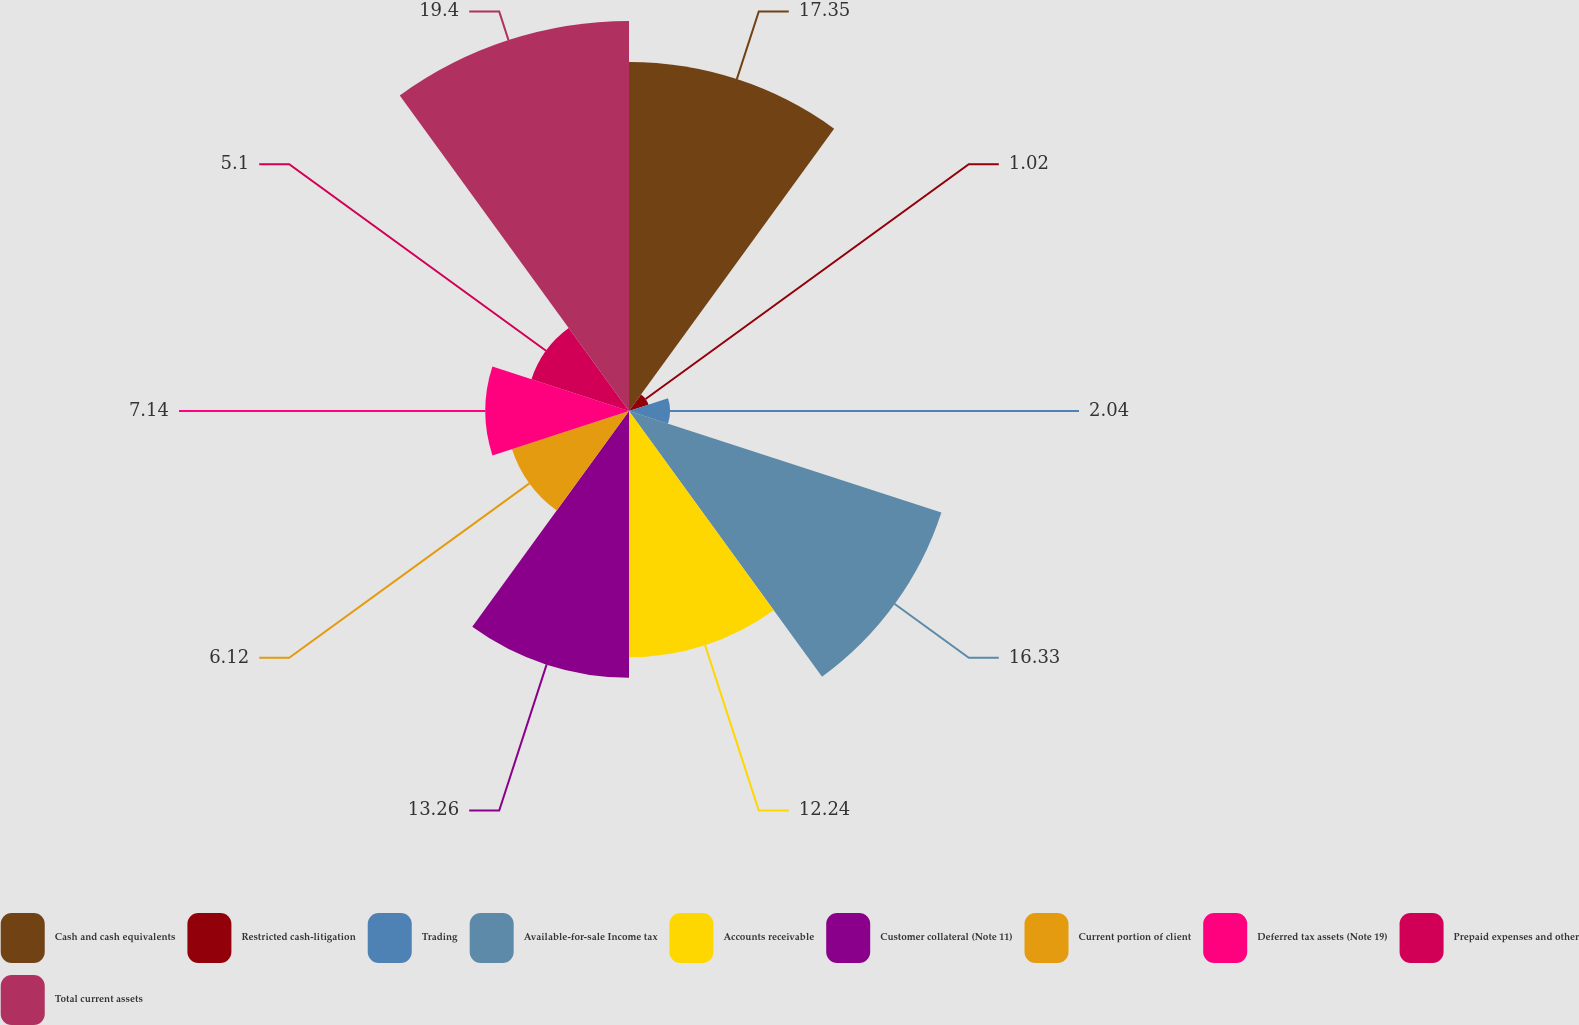Convert chart. <chart><loc_0><loc_0><loc_500><loc_500><pie_chart><fcel>Cash and cash equivalents<fcel>Restricted cash-litigation<fcel>Trading<fcel>Available-for-sale Income tax<fcel>Accounts receivable<fcel>Customer collateral (Note 11)<fcel>Current portion of client<fcel>Deferred tax assets (Note 19)<fcel>Prepaid expenses and other<fcel>Total current assets<nl><fcel>17.35%<fcel>1.02%<fcel>2.04%<fcel>16.33%<fcel>12.24%<fcel>13.26%<fcel>6.12%<fcel>7.14%<fcel>5.1%<fcel>19.39%<nl></chart> 